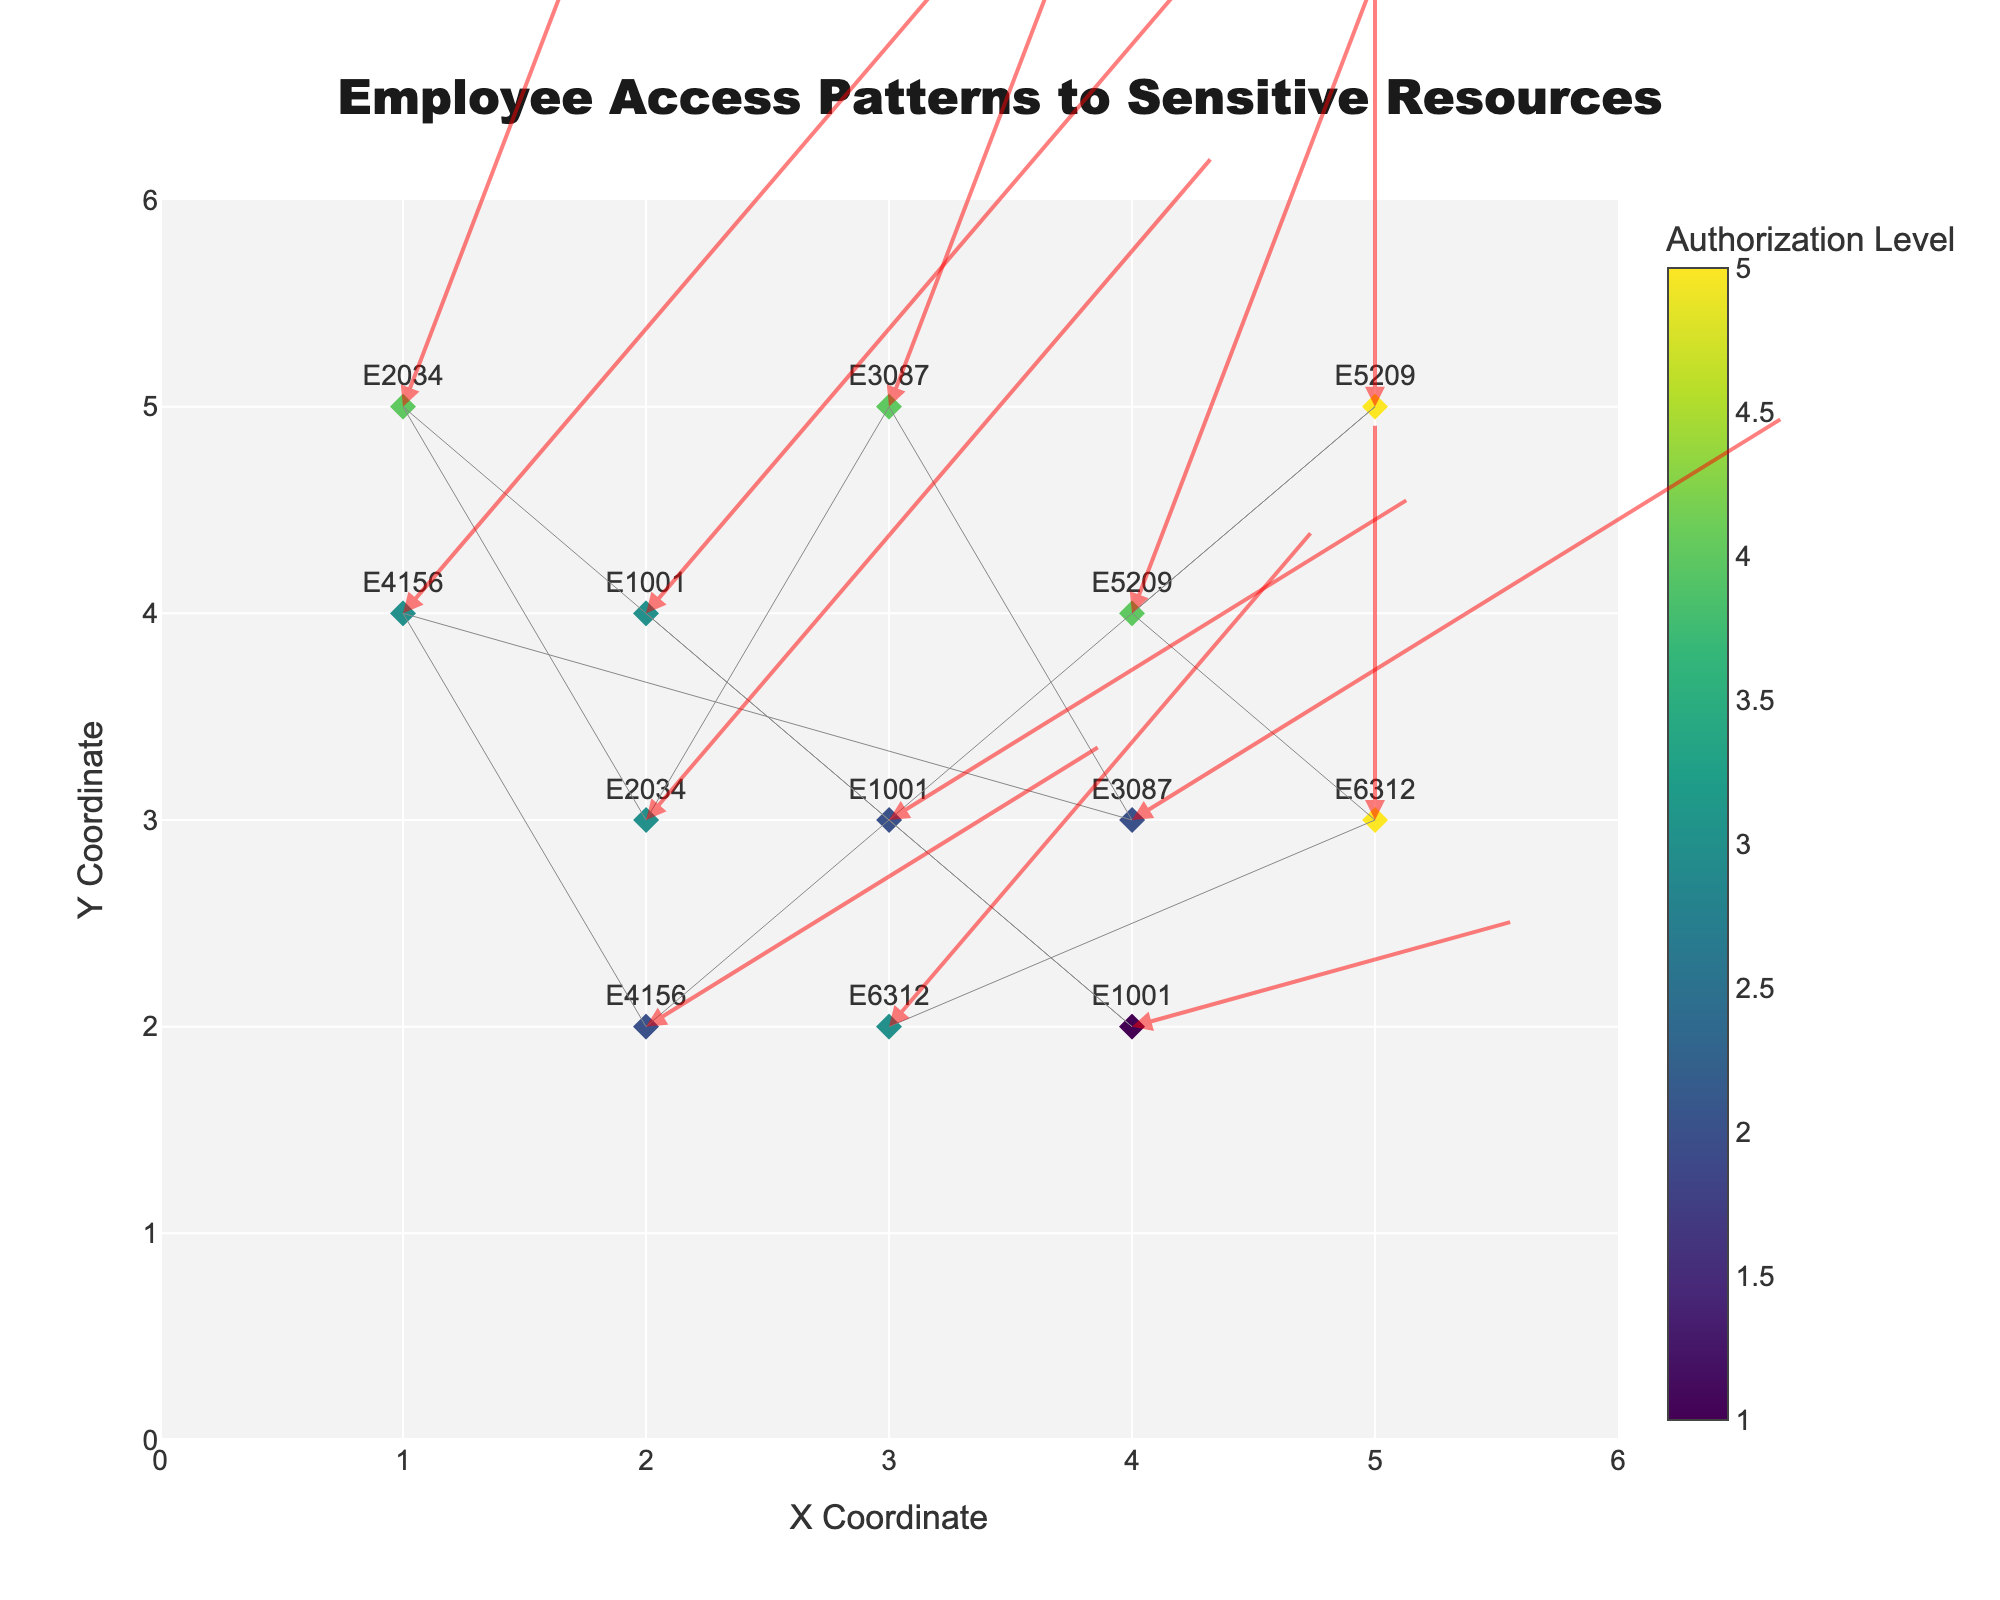what is the total number of data points in the plot? Count the number of unique resource interactions listed in the dataset. Each row represents a data point in the plot. There are 13 rows in the dataset.
Answer: 13 Which employee has accessed the 'Security_Logs' and what is their authorization level? Refer to the interactions listed in the dataset for 'Security_Logs'. The employee accessing 'Security_Logs' is E5209 with an authorization level of 5.
Answer: E5209, 5 What is the x and y coordinate range in the figure? Examine the x and y axis tick marks on the quiver plot. Both axes range from 0 to 6.
Answer: 0 to 6 Between employee E3087 accessing 'Firewall_Settings' and 'Code_Repository', which resource has a higher access frequency? Compare the access frequency values for 'Firewall_Settings' and 'Code_Repository' for E3087 from the dataset. 'Firewall_Settings' has a frequency of 18 and 'Code_Repository' has a frequency of 10.
Answer: Firewall_Settings What is the average authorization level for employee E1001's interactions? Calculate the average of the authorization levels for E1001's interactions: (3 + 2 + 1) / 3 = 2.
Answer: 2 Which data interaction has the largest arrow or vector length in the quiver plot? The arrow length is determined by the access frequency, which is scaled by cosine and sine values. The largest access frequency is for the interaction with 'Security_Logs', which has a frequency of 30.
Answer: Security_Logs How does the color of the arrows vary among different authorization levels? The color scale is applied based on the authorization level, shown on the legend. Higher authorization levels have darker colors while lower levels have lighter colors.
Answer: Darker for higher, lighter for lower What is the most accessed resource by employee E4156? Compare the access frequency of the resources accessed by E4156: 'Email_Server' has a frequency of 25 and 'Backup_Systems' has a frequency of 7.
Answer: Email_Server Among all employees, which resource has the highest average authorization level? Calculate the average authorization level for each resource and identify the highest value. 'Password_Database' has an average authorization level of 5.
Answer: Password_Database 